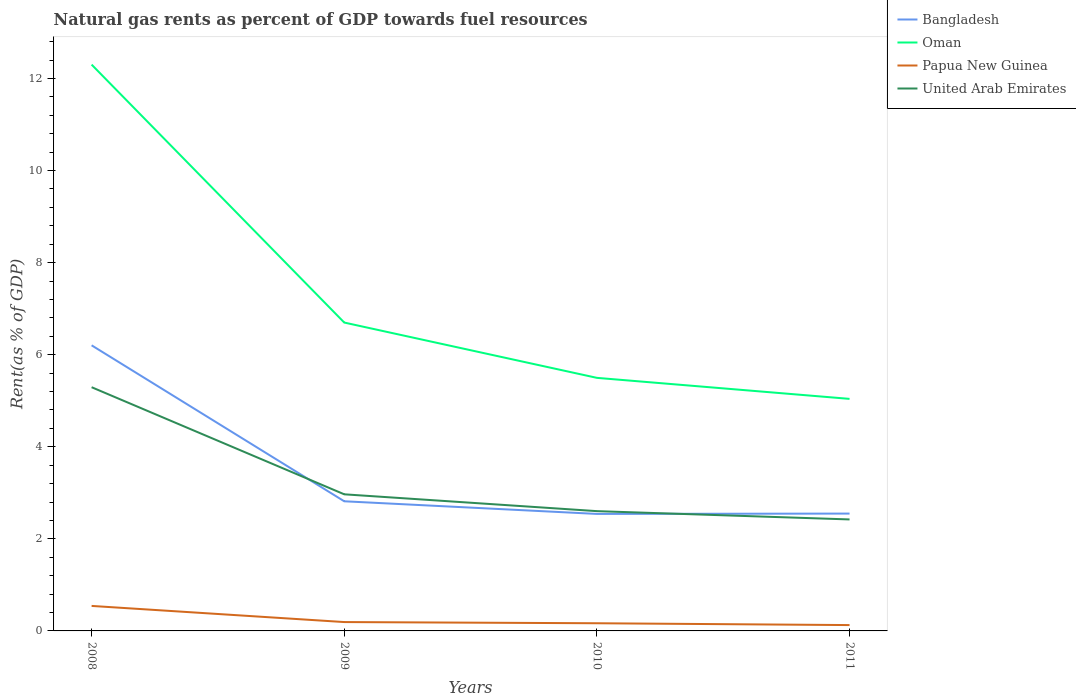How many different coloured lines are there?
Give a very brief answer. 4. Does the line corresponding to Oman intersect with the line corresponding to Bangladesh?
Provide a short and direct response. No. Across all years, what is the maximum matural gas rent in Bangladesh?
Provide a succinct answer. 2.54. What is the total matural gas rent in Bangladesh in the graph?
Provide a succinct answer. 3.39. What is the difference between the highest and the second highest matural gas rent in Papua New Guinea?
Provide a short and direct response. 0.42. Is the matural gas rent in Bangladesh strictly greater than the matural gas rent in Papua New Guinea over the years?
Your answer should be compact. No. How many years are there in the graph?
Make the answer very short. 4. Does the graph contain any zero values?
Provide a succinct answer. No. Where does the legend appear in the graph?
Make the answer very short. Top right. How are the legend labels stacked?
Provide a succinct answer. Vertical. What is the title of the graph?
Your response must be concise. Natural gas rents as percent of GDP towards fuel resources. What is the label or title of the Y-axis?
Keep it short and to the point. Rent(as % of GDP). What is the Rent(as % of GDP) in Bangladesh in 2008?
Make the answer very short. 6.2. What is the Rent(as % of GDP) in Oman in 2008?
Offer a terse response. 12.3. What is the Rent(as % of GDP) in Papua New Guinea in 2008?
Offer a very short reply. 0.54. What is the Rent(as % of GDP) in United Arab Emirates in 2008?
Keep it short and to the point. 5.29. What is the Rent(as % of GDP) of Bangladesh in 2009?
Give a very brief answer. 2.82. What is the Rent(as % of GDP) in Oman in 2009?
Offer a very short reply. 6.7. What is the Rent(as % of GDP) of Papua New Guinea in 2009?
Give a very brief answer. 0.19. What is the Rent(as % of GDP) in United Arab Emirates in 2009?
Your response must be concise. 2.97. What is the Rent(as % of GDP) of Bangladesh in 2010?
Your answer should be compact. 2.54. What is the Rent(as % of GDP) of Oman in 2010?
Give a very brief answer. 5.5. What is the Rent(as % of GDP) of Papua New Guinea in 2010?
Offer a terse response. 0.17. What is the Rent(as % of GDP) in United Arab Emirates in 2010?
Provide a succinct answer. 2.6. What is the Rent(as % of GDP) of Bangladesh in 2011?
Your answer should be compact. 2.55. What is the Rent(as % of GDP) in Oman in 2011?
Your answer should be compact. 5.04. What is the Rent(as % of GDP) in Papua New Guinea in 2011?
Provide a succinct answer. 0.13. What is the Rent(as % of GDP) in United Arab Emirates in 2011?
Your answer should be compact. 2.42. Across all years, what is the maximum Rent(as % of GDP) in Bangladesh?
Provide a succinct answer. 6.2. Across all years, what is the maximum Rent(as % of GDP) of Oman?
Your answer should be compact. 12.3. Across all years, what is the maximum Rent(as % of GDP) in Papua New Guinea?
Give a very brief answer. 0.54. Across all years, what is the maximum Rent(as % of GDP) of United Arab Emirates?
Keep it short and to the point. 5.29. Across all years, what is the minimum Rent(as % of GDP) in Bangladesh?
Provide a succinct answer. 2.54. Across all years, what is the minimum Rent(as % of GDP) in Oman?
Keep it short and to the point. 5.04. Across all years, what is the minimum Rent(as % of GDP) in Papua New Guinea?
Provide a short and direct response. 0.13. Across all years, what is the minimum Rent(as % of GDP) in United Arab Emirates?
Your answer should be compact. 2.42. What is the total Rent(as % of GDP) in Bangladesh in the graph?
Make the answer very short. 14.11. What is the total Rent(as % of GDP) of Oman in the graph?
Keep it short and to the point. 29.54. What is the total Rent(as % of GDP) in Papua New Guinea in the graph?
Offer a terse response. 1.03. What is the total Rent(as % of GDP) of United Arab Emirates in the graph?
Offer a terse response. 13.29. What is the difference between the Rent(as % of GDP) in Bangladesh in 2008 and that in 2009?
Provide a short and direct response. 3.39. What is the difference between the Rent(as % of GDP) in Oman in 2008 and that in 2009?
Offer a terse response. 5.6. What is the difference between the Rent(as % of GDP) of Papua New Guinea in 2008 and that in 2009?
Your response must be concise. 0.35. What is the difference between the Rent(as % of GDP) in United Arab Emirates in 2008 and that in 2009?
Offer a very short reply. 2.33. What is the difference between the Rent(as % of GDP) of Bangladesh in 2008 and that in 2010?
Provide a short and direct response. 3.66. What is the difference between the Rent(as % of GDP) in Oman in 2008 and that in 2010?
Provide a succinct answer. 6.8. What is the difference between the Rent(as % of GDP) in Papua New Guinea in 2008 and that in 2010?
Provide a succinct answer. 0.38. What is the difference between the Rent(as % of GDP) in United Arab Emirates in 2008 and that in 2010?
Give a very brief answer. 2.69. What is the difference between the Rent(as % of GDP) of Bangladesh in 2008 and that in 2011?
Offer a very short reply. 3.66. What is the difference between the Rent(as % of GDP) in Oman in 2008 and that in 2011?
Give a very brief answer. 7.26. What is the difference between the Rent(as % of GDP) of Papua New Guinea in 2008 and that in 2011?
Your answer should be compact. 0.42. What is the difference between the Rent(as % of GDP) in United Arab Emirates in 2008 and that in 2011?
Your answer should be compact. 2.87. What is the difference between the Rent(as % of GDP) in Bangladesh in 2009 and that in 2010?
Provide a succinct answer. 0.27. What is the difference between the Rent(as % of GDP) in Oman in 2009 and that in 2010?
Make the answer very short. 1.2. What is the difference between the Rent(as % of GDP) in Papua New Guinea in 2009 and that in 2010?
Offer a terse response. 0.03. What is the difference between the Rent(as % of GDP) of United Arab Emirates in 2009 and that in 2010?
Your answer should be very brief. 0.37. What is the difference between the Rent(as % of GDP) of Bangladesh in 2009 and that in 2011?
Keep it short and to the point. 0.27. What is the difference between the Rent(as % of GDP) of Oman in 2009 and that in 2011?
Keep it short and to the point. 1.66. What is the difference between the Rent(as % of GDP) of Papua New Guinea in 2009 and that in 2011?
Offer a very short reply. 0.07. What is the difference between the Rent(as % of GDP) of United Arab Emirates in 2009 and that in 2011?
Your answer should be compact. 0.55. What is the difference between the Rent(as % of GDP) in Bangladesh in 2010 and that in 2011?
Your answer should be very brief. -0.01. What is the difference between the Rent(as % of GDP) in Oman in 2010 and that in 2011?
Ensure brevity in your answer.  0.46. What is the difference between the Rent(as % of GDP) in Papua New Guinea in 2010 and that in 2011?
Give a very brief answer. 0.04. What is the difference between the Rent(as % of GDP) of United Arab Emirates in 2010 and that in 2011?
Your answer should be very brief. 0.18. What is the difference between the Rent(as % of GDP) in Bangladesh in 2008 and the Rent(as % of GDP) in Oman in 2009?
Offer a very short reply. -0.49. What is the difference between the Rent(as % of GDP) of Bangladesh in 2008 and the Rent(as % of GDP) of Papua New Guinea in 2009?
Keep it short and to the point. 6.01. What is the difference between the Rent(as % of GDP) of Bangladesh in 2008 and the Rent(as % of GDP) of United Arab Emirates in 2009?
Keep it short and to the point. 3.24. What is the difference between the Rent(as % of GDP) of Oman in 2008 and the Rent(as % of GDP) of Papua New Guinea in 2009?
Your answer should be compact. 12.11. What is the difference between the Rent(as % of GDP) of Oman in 2008 and the Rent(as % of GDP) of United Arab Emirates in 2009?
Offer a very short reply. 9.33. What is the difference between the Rent(as % of GDP) of Papua New Guinea in 2008 and the Rent(as % of GDP) of United Arab Emirates in 2009?
Provide a short and direct response. -2.42. What is the difference between the Rent(as % of GDP) in Bangladesh in 2008 and the Rent(as % of GDP) in Oman in 2010?
Offer a very short reply. 0.71. What is the difference between the Rent(as % of GDP) of Bangladesh in 2008 and the Rent(as % of GDP) of Papua New Guinea in 2010?
Your response must be concise. 6.04. What is the difference between the Rent(as % of GDP) of Bangladesh in 2008 and the Rent(as % of GDP) of United Arab Emirates in 2010?
Offer a very short reply. 3.6. What is the difference between the Rent(as % of GDP) of Oman in 2008 and the Rent(as % of GDP) of Papua New Guinea in 2010?
Provide a succinct answer. 12.14. What is the difference between the Rent(as % of GDP) in Oman in 2008 and the Rent(as % of GDP) in United Arab Emirates in 2010?
Make the answer very short. 9.7. What is the difference between the Rent(as % of GDP) of Papua New Guinea in 2008 and the Rent(as % of GDP) of United Arab Emirates in 2010?
Offer a terse response. -2.06. What is the difference between the Rent(as % of GDP) in Bangladesh in 2008 and the Rent(as % of GDP) in Oman in 2011?
Keep it short and to the point. 1.16. What is the difference between the Rent(as % of GDP) in Bangladesh in 2008 and the Rent(as % of GDP) in Papua New Guinea in 2011?
Make the answer very short. 6.08. What is the difference between the Rent(as % of GDP) of Bangladesh in 2008 and the Rent(as % of GDP) of United Arab Emirates in 2011?
Provide a succinct answer. 3.78. What is the difference between the Rent(as % of GDP) in Oman in 2008 and the Rent(as % of GDP) in Papua New Guinea in 2011?
Your answer should be very brief. 12.18. What is the difference between the Rent(as % of GDP) of Oman in 2008 and the Rent(as % of GDP) of United Arab Emirates in 2011?
Your answer should be compact. 9.88. What is the difference between the Rent(as % of GDP) of Papua New Guinea in 2008 and the Rent(as % of GDP) of United Arab Emirates in 2011?
Offer a terse response. -1.88. What is the difference between the Rent(as % of GDP) of Bangladesh in 2009 and the Rent(as % of GDP) of Oman in 2010?
Make the answer very short. -2.68. What is the difference between the Rent(as % of GDP) of Bangladesh in 2009 and the Rent(as % of GDP) of Papua New Guinea in 2010?
Keep it short and to the point. 2.65. What is the difference between the Rent(as % of GDP) in Bangladesh in 2009 and the Rent(as % of GDP) in United Arab Emirates in 2010?
Ensure brevity in your answer.  0.21. What is the difference between the Rent(as % of GDP) in Oman in 2009 and the Rent(as % of GDP) in Papua New Guinea in 2010?
Make the answer very short. 6.53. What is the difference between the Rent(as % of GDP) of Oman in 2009 and the Rent(as % of GDP) of United Arab Emirates in 2010?
Offer a terse response. 4.1. What is the difference between the Rent(as % of GDP) in Papua New Guinea in 2009 and the Rent(as % of GDP) in United Arab Emirates in 2010?
Provide a short and direct response. -2.41. What is the difference between the Rent(as % of GDP) of Bangladesh in 2009 and the Rent(as % of GDP) of Oman in 2011?
Keep it short and to the point. -2.22. What is the difference between the Rent(as % of GDP) of Bangladesh in 2009 and the Rent(as % of GDP) of Papua New Guinea in 2011?
Provide a succinct answer. 2.69. What is the difference between the Rent(as % of GDP) in Bangladesh in 2009 and the Rent(as % of GDP) in United Arab Emirates in 2011?
Make the answer very short. 0.39. What is the difference between the Rent(as % of GDP) in Oman in 2009 and the Rent(as % of GDP) in Papua New Guinea in 2011?
Make the answer very short. 6.57. What is the difference between the Rent(as % of GDP) in Oman in 2009 and the Rent(as % of GDP) in United Arab Emirates in 2011?
Keep it short and to the point. 4.28. What is the difference between the Rent(as % of GDP) of Papua New Guinea in 2009 and the Rent(as % of GDP) of United Arab Emirates in 2011?
Offer a very short reply. -2.23. What is the difference between the Rent(as % of GDP) in Bangladesh in 2010 and the Rent(as % of GDP) in Oman in 2011?
Make the answer very short. -2.5. What is the difference between the Rent(as % of GDP) of Bangladesh in 2010 and the Rent(as % of GDP) of Papua New Guinea in 2011?
Keep it short and to the point. 2.41. What is the difference between the Rent(as % of GDP) in Bangladesh in 2010 and the Rent(as % of GDP) in United Arab Emirates in 2011?
Your answer should be very brief. 0.12. What is the difference between the Rent(as % of GDP) in Oman in 2010 and the Rent(as % of GDP) in Papua New Guinea in 2011?
Your answer should be compact. 5.37. What is the difference between the Rent(as % of GDP) in Oman in 2010 and the Rent(as % of GDP) in United Arab Emirates in 2011?
Your response must be concise. 3.08. What is the difference between the Rent(as % of GDP) of Papua New Guinea in 2010 and the Rent(as % of GDP) of United Arab Emirates in 2011?
Keep it short and to the point. -2.26. What is the average Rent(as % of GDP) in Bangladesh per year?
Offer a terse response. 3.53. What is the average Rent(as % of GDP) of Oman per year?
Provide a short and direct response. 7.38. What is the average Rent(as % of GDP) of Papua New Guinea per year?
Provide a succinct answer. 0.26. What is the average Rent(as % of GDP) in United Arab Emirates per year?
Ensure brevity in your answer.  3.32. In the year 2008, what is the difference between the Rent(as % of GDP) of Bangladesh and Rent(as % of GDP) of Oman?
Give a very brief answer. -6.1. In the year 2008, what is the difference between the Rent(as % of GDP) of Bangladesh and Rent(as % of GDP) of Papua New Guinea?
Your response must be concise. 5.66. In the year 2008, what is the difference between the Rent(as % of GDP) in Bangladesh and Rent(as % of GDP) in United Arab Emirates?
Keep it short and to the point. 0.91. In the year 2008, what is the difference between the Rent(as % of GDP) in Oman and Rent(as % of GDP) in Papua New Guinea?
Offer a terse response. 11.76. In the year 2008, what is the difference between the Rent(as % of GDP) in Oman and Rent(as % of GDP) in United Arab Emirates?
Keep it short and to the point. 7.01. In the year 2008, what is the difference between the Rent(as % of GDP) of Papua New Guinea and Rent(as % of GDP) of United Arab Emirates?
Offer a terse response. -4.75. In the year 2009, what is the difference between the Rent(as % of GDP) in Bangladesh and Rent(as % of GDP) in Oman?
Keep it short and to the point. -3.88. In the year 2009, what is the difference between the Rent(as % of GDP) in Bangladesh and Rent(as % of GDP) in Papua New Guinea?
Provide a succinct answer. 2.62. In the year 2009, what is the difference between the Rent(as % of GDP) in Bangladesh and Rent(as % of GDP) in United Arab Emirates?
Your answer should be very brief. -0.15. In the year 2009, what is the difference between the Rent(as % of GDP) of Oman and Rent(as % of GDP) of Papua New Guinea?
Offer a very short reply. 6.51. In the year 2009, what is the difference between the Rent(as % of GDP) in Oman and Rent(as % of GDP) in United Arab Emirates?
Keep it short and to the point. 3.73. In the year 2009, what is the difference between the Rent(as % of GDP) in Papua New Guinea and Rent(as % of GDP) in United Arab Emirates?
Provide a short and direct response. -2.78. In the year 2010, what is the difference between the Rent(as % of GDP) in Bangladesh and Rent(as % of GDP) in Oman?
Keep it short and to the point. -2.96. In the year 2010, what is the difference between the Rent(as % of GDP) of Bangladesh and Rent(as % of GDP) of Papua New Guinea?
Provide a short and direct response. 2.37. In the year 2010, what is the difference between the Rent(as % of GDP) in Bangladesh and Rent(as % of GDP) in United Arab Emirates?
Offer a terse response. -0.06. In the year 2010, what is the difference between the Rent(as % of GDP) in Oman and Rent(as % of GDP) in Papua New Guinea?
Keep it short and to the point. 5.33. In the year 2010, what is the difference between the Rent(as % of GDP) in Oman and Rent(as % of GDP) in United Arab Emirates?
Give a very brief answer. 2.9. In the year 2010, what is the difference between the Rent(as % of GDP) in Papua New Guinea and Rent(as % of GDP) in United Arab Emirates?
Your answer should be compact. -2.44. In the year 2011, what is the difference between the Rent(as % of GDP) of Bangladesh and Rent(as % of GDP) of Oman?
Provide a succinct answer. -2.49. In the year 2011, what is the difference between the Rent(as % of GDP) of Bangladesh and Rent(as % of GDP) of Papua New Guinea?
Your answer should be compact. 2.42. In the year 2011, what is the difference between the Rent(as % of GDP) of Bangladesh and Rent(as % of GDP) of United Arab Emirates?
Offer a terse response. 0.13. In the year 2011, what is the difference between the Rent(as % of GDP) of Oman and Rent(as % of GDP) of Papua New Guinea?
Offer a terse response. 4.91. In the year 2011, what is the difference between the Rent(as % of GDP) in Oman and Rent(as % of GDP) in United Arab Emirates?
Your answer should be very brief. 2.62. In the year 2011, what is the difference between the Rent(as % of GDP) in Papua New Guinea and Rent(as % of GDP) in United Arab Emirates?
Your response must be concise. -2.29. What is the ratio of the Rent(as % of GDP) in Bangladesh in 2008 to that in 2009?
Your answer should be compact. 2.2. What is the ratio of the Rent(as % of GDP) of Oman in 2008 to that in 2009?
Your answer should be very brief. 1.84. What is the ratio of the Rent(as % of GDP) of Papua New Guinea in 2008 to that in 2009?
Keep it short and to the point. 2.82. What is the ratio of the Rent(as % of GDP) of United Arab Emirates in 2008 to that in 2009?
Give a very brief answer. 1.78. What is the ratio of the Rent(as % of GDP) in Bangladesh in 2008 to that in 2010?
Your response must be concise. 2.44. What is the ratio of the Rent(as % of GDP) of Oman in 2008 to that in 2010?
Your response must be concise. 2.24. What is the ratio of the Rent(as % of GDP) of Papua New Guinea in 2008 to that in 2010?
Ensure brevity in your answer.  3.26. What is the ratio of the Rent(as % of GDP) of United Arab Emirates in 2008 to that in 2010?
Ensure brevity in your answer.  2.03. What is the ratio of the Rent(as % of GDP) in Bangladesh in 2008 to that in 2011?
Provide a succinct answer. 2.43. What is the ratio of the Rent(as % of GDP) of Oman in 2008 to that in 2011?
Offer a terse response. 2.44. What is the ratio of the Rent(as % of GDP) of Papua New Guinea in 2008 to that in 2011?
Make the answer very short. 4.28. What is the ratio of the Rent(as % of GDP) in United Arab Emirates in 2008 to that in 2011?
Provide a succinct answer. 2.19. What is the ratio of the Rent(as % of GDP) of Bangladesh in 2009 to that in 2010?
Make the answer very short. 1.11. What is the ratio of the Rent(as % of GDP) of Oman in 2009 to that in 2010?
Make the answer very short. 1.22. What is the ratio of the Rent(as % of GDP) in Papua New Guinea in 2009 to that in 2010?
Offer a terse response. 1.15. What is the ratio of the Rent(as % of GDP) of United Arab Emirates in 2009 to that in 2010?
Provide a short and direct response. 1.14. What is the ratio of the Rent(as % of GDP) of Bangladesh in 2009 to that in 2011?
Your answer should be very brief. 1.1. What is the ratio of the Rent(as % of GDP) in Oman in 2009 to that in 2011?
Provide a short and direct response. 1.33. What is the ratio of the Rent(as % of GDP) in Papua New Guinea in 2009 to that in 2011?
Offer a very short reply. 1.52. What is the ratio of the Rent(as % of GDP) of United Arab Emirates in 2009 to that in 2011?
Your answer should be very brief. 1.23. What is the ratio of the Rent(as % of GDP) in Oman in 2010 to that in 2011?
Offer a very short reply. 1.09. What is the ratio of the Rent(as % of GDP) in Papua New Guinea in 2010 to that in 2011?
Provide a short and direct response. 1.31. What is the ratio of the Rent(as % of GDP) in United Arab Emirates in 2010 to that in 2011?
Offer a terse response. 1.07. What is the difference between the highest and the second highest Rent(as % of GDP) of Bangladesh?
Provide a succinct answer. 3.39. What is the difference between the highest and the second highest Rent(as % of GDP) of Oman?
Provide a succinct answer. 5.6. What is the difference between the highest and the second highest Rent(as % of GDP) in Papua New Guinea?
Ensure brevity in your answer.  0.35. What is the difference between the highest and the second highest Rent(as % of GDP) in United Arab Emirates?
Your answer should be very brief. 2.33. What is the difference between the highest and the lowest Rent(as % of GDP) of Bangladesh?
Your answer should be very brief. 3.66. What is the difference between the highest and the lowest Rent(as % of GDP) in Oman?
Offer a very short reply. 7.26. What is the difference between the highest and the lowest Rent(as % of GDP) of Papua New Guinea?
Your answer should be very brief. 0.42. What is the difference between the highest and the lowest Rent(as % of GDP) in United Arab Emirates?
Offer a terse response. 2.87. 